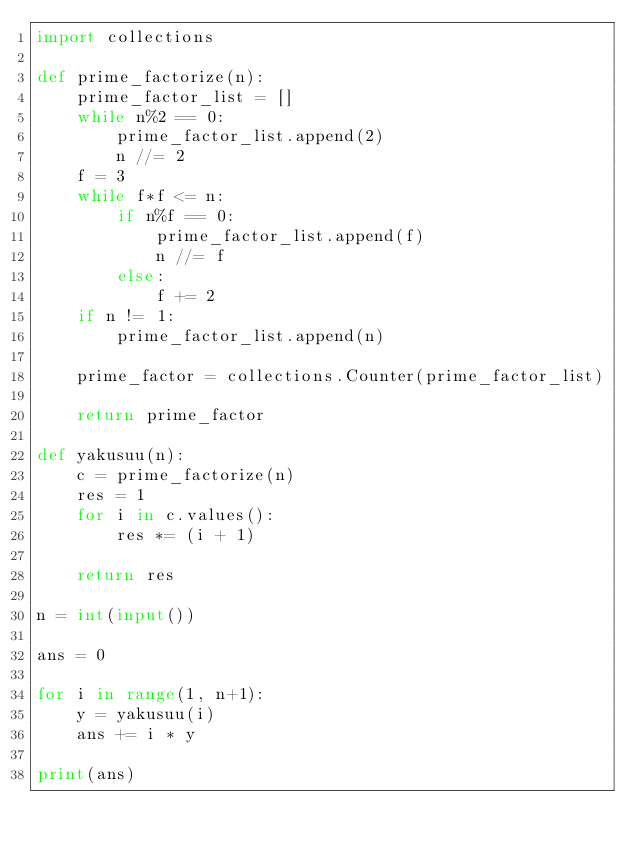<code> <loc_0><loc_0><loc_500><loc_500><_Python_>import collections

def prime_factorize(n):
    prime_factor_list = []
    while n%2 == 0:
        prime_factor_list.append(2)
        n //= 2
    f = 3
    while f*f <= n:
        if n%f == 0:
            prime_factor_list.append(f)
            n //= f
        else:
            f += 2
    if n != 1:
        prime_factor_list.append(n)
    
    prime_factor = collections.Counter(prime_factor_list)

    return prime_factor

def yakusuu(n):
    c = prime_factorize(n)
    res = 1
    for i in c.values():
        res *= (i + 1)
    
    return res

n = int(input())

ans = 0

for i in range(1, n+1):
    y = yakusuu(i)
    ans += i * y

print(ans)
</code> 